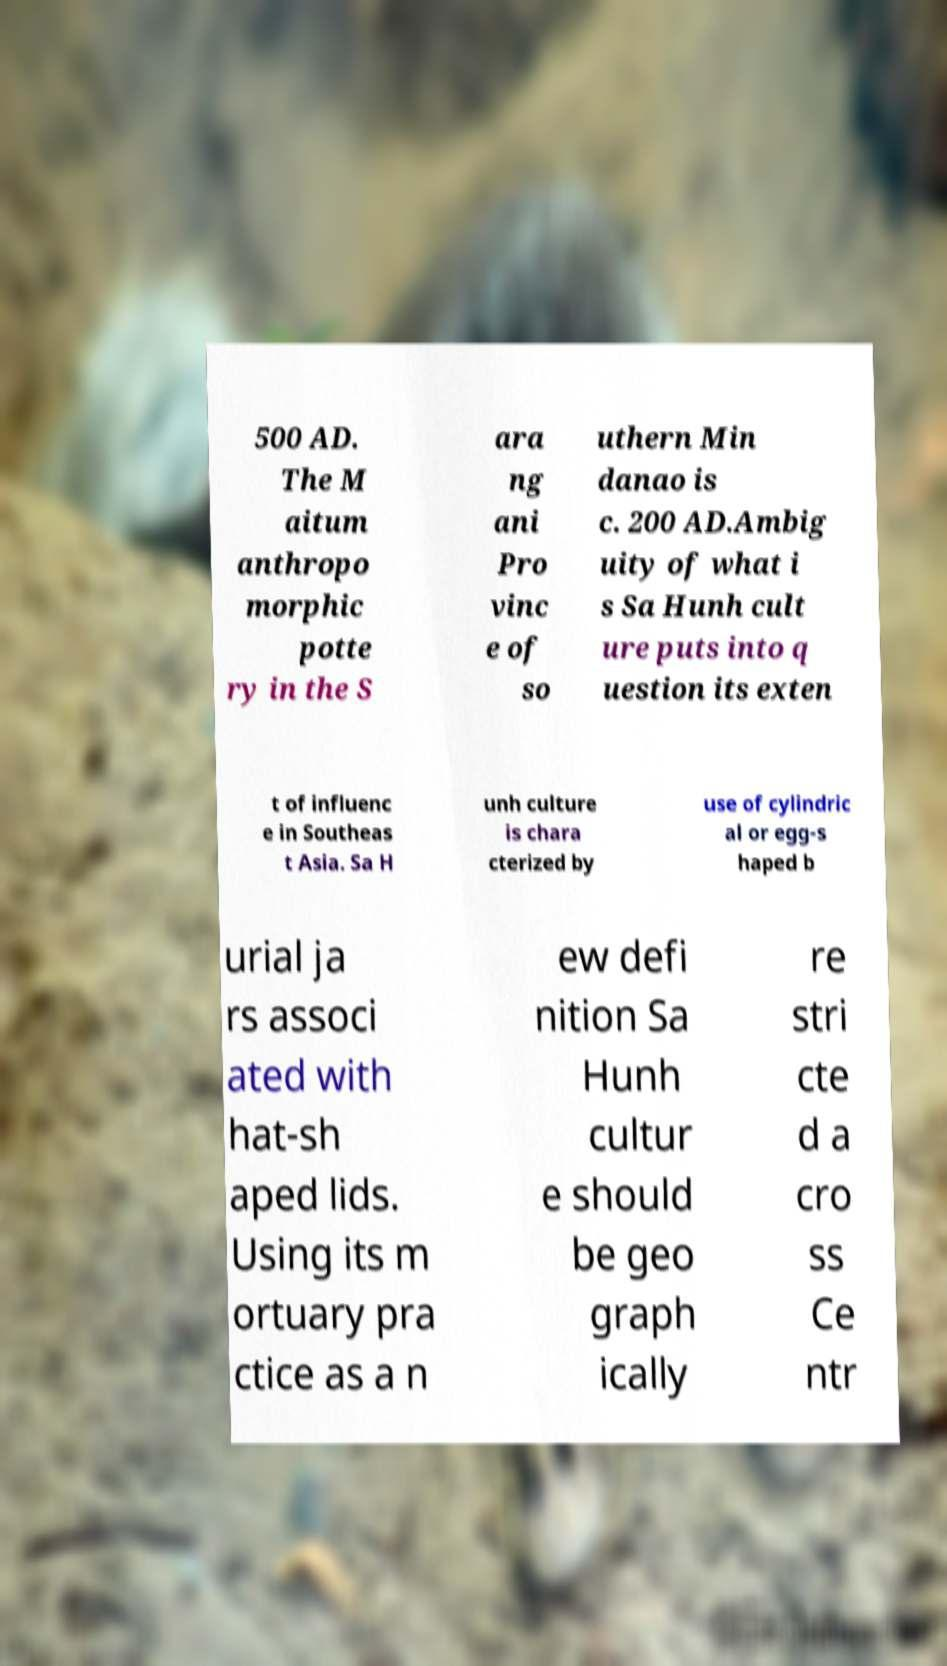What messages or text are displayed in this image? I need them in a readable, typed format. 500 AD. The M aitum anthropo morphic potte ry in the S ara ng ani Pro vinc e of so uthern Min danao is c. 200 AD.Ambig uity of what i s Sa Hunh cult ure puts into q uestion its exten t of influenc e in Southeas t Asia. Sa H unh culture is chara cterized by use of cylindric al or egg-s haped b urial ja rs associ ated with hat-sh aped lids. Using its m ortuary pra ctice as a n ew defi nition Sa Hunh cultur e should be geo graph ically re stri cte d a cro ss Ce ntr 